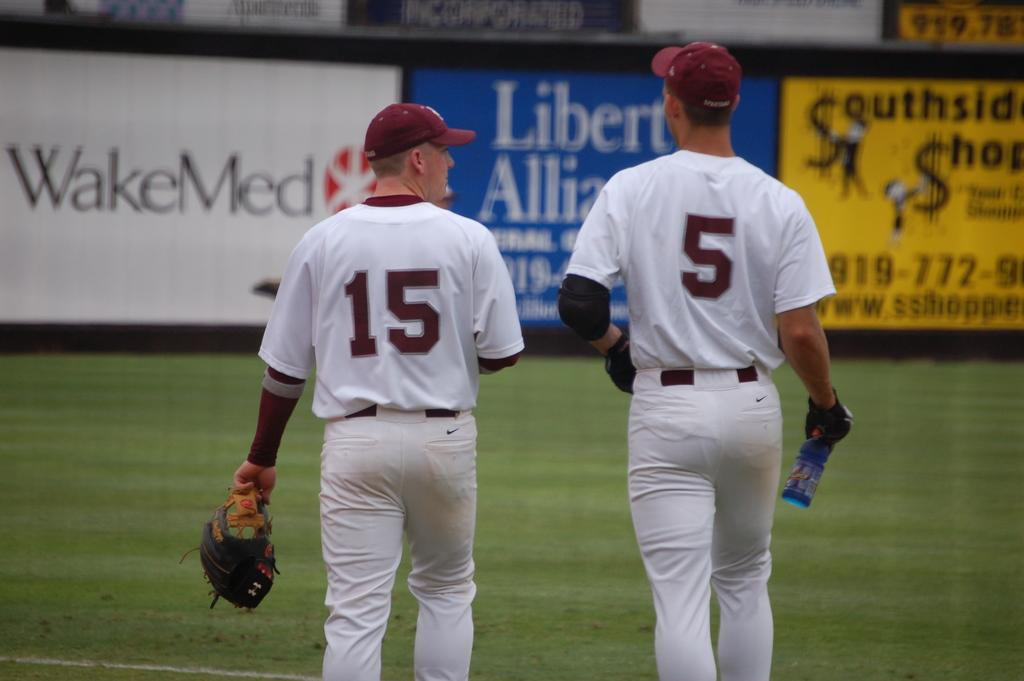<image>
Offer a succinct explanation of the picture presented. Baseball player wearing number 15 standing next to a guy wearing number 5 